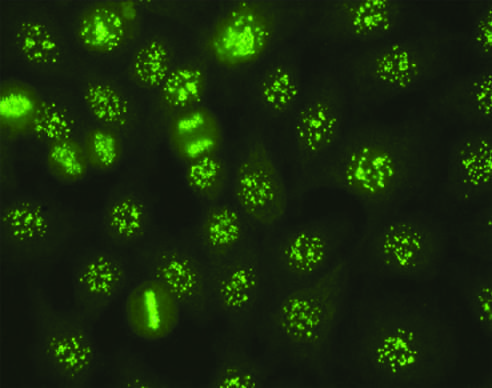s the principal cellular alterations that characterize reversible cell injury and necrosis seen in some cases of systemic sclerosis, sjogren syndrome, and other diseases?
Answer the question using a single word or phrase. No 